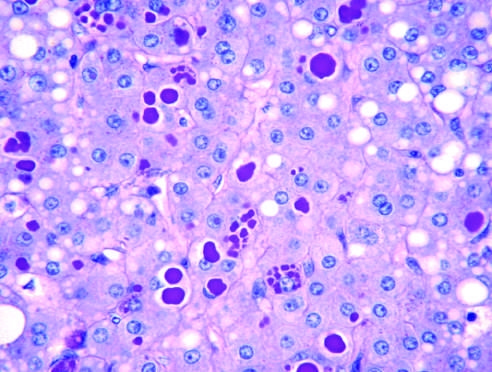when does periodic acid-schiff stain?
Answer the question using a single word or phrase. After diastase digestion of the liver 